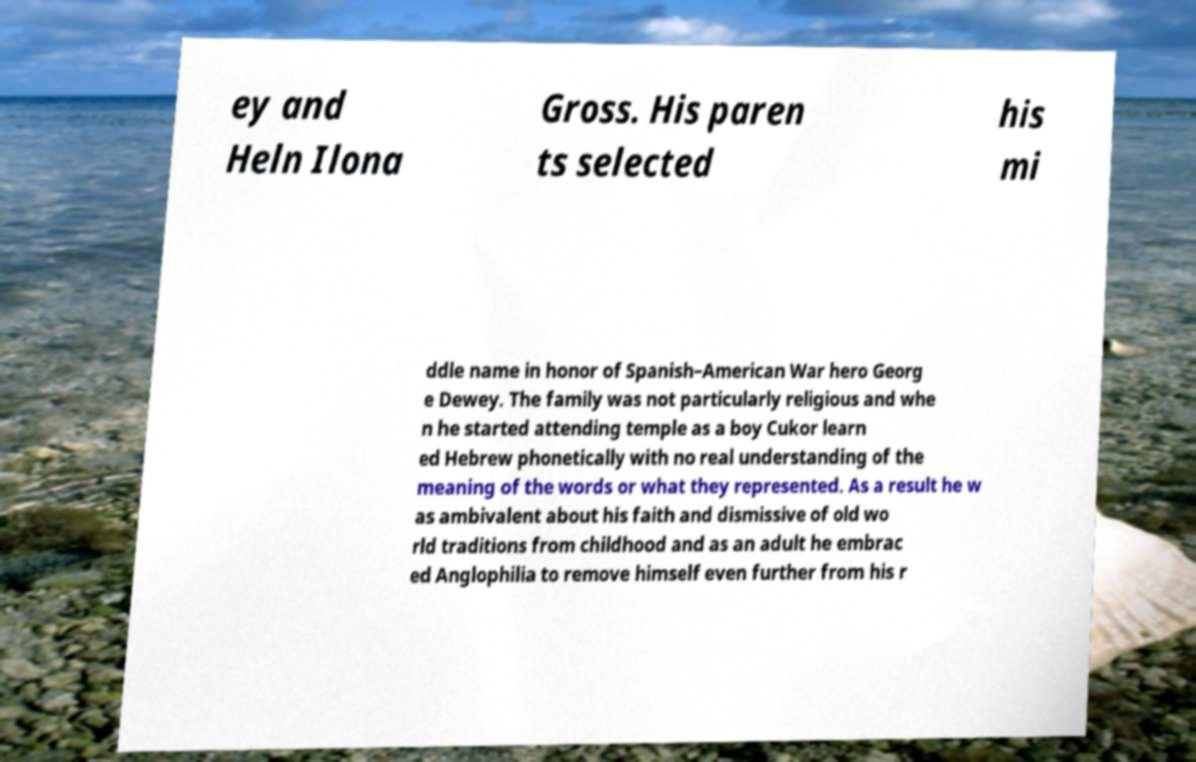I need the written content from this picture converted into text. Can you do that? ey and Heln Ilona Gross. His paren ts selected his mi ddle name in honor of Spanish–American War hero Georg e Dewey. The family was not particularly religious and whe n he started attending temple as a boy Cukor learn ed Hebrew phonetically with no real understanding of the meaning of the words or what they represented. As a result he w as ambivalent about his faith and dismissive of old wo rld traditions from childhood and as an adult he embrac ed Anglophilia to remove himself even further from his r 